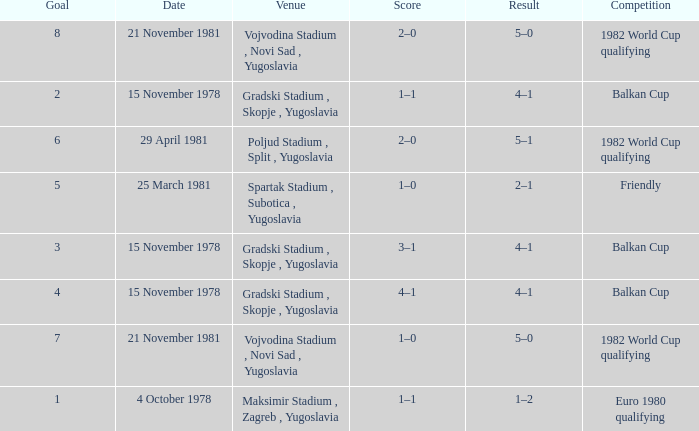What is the Result for Goal 3? 4–1. 